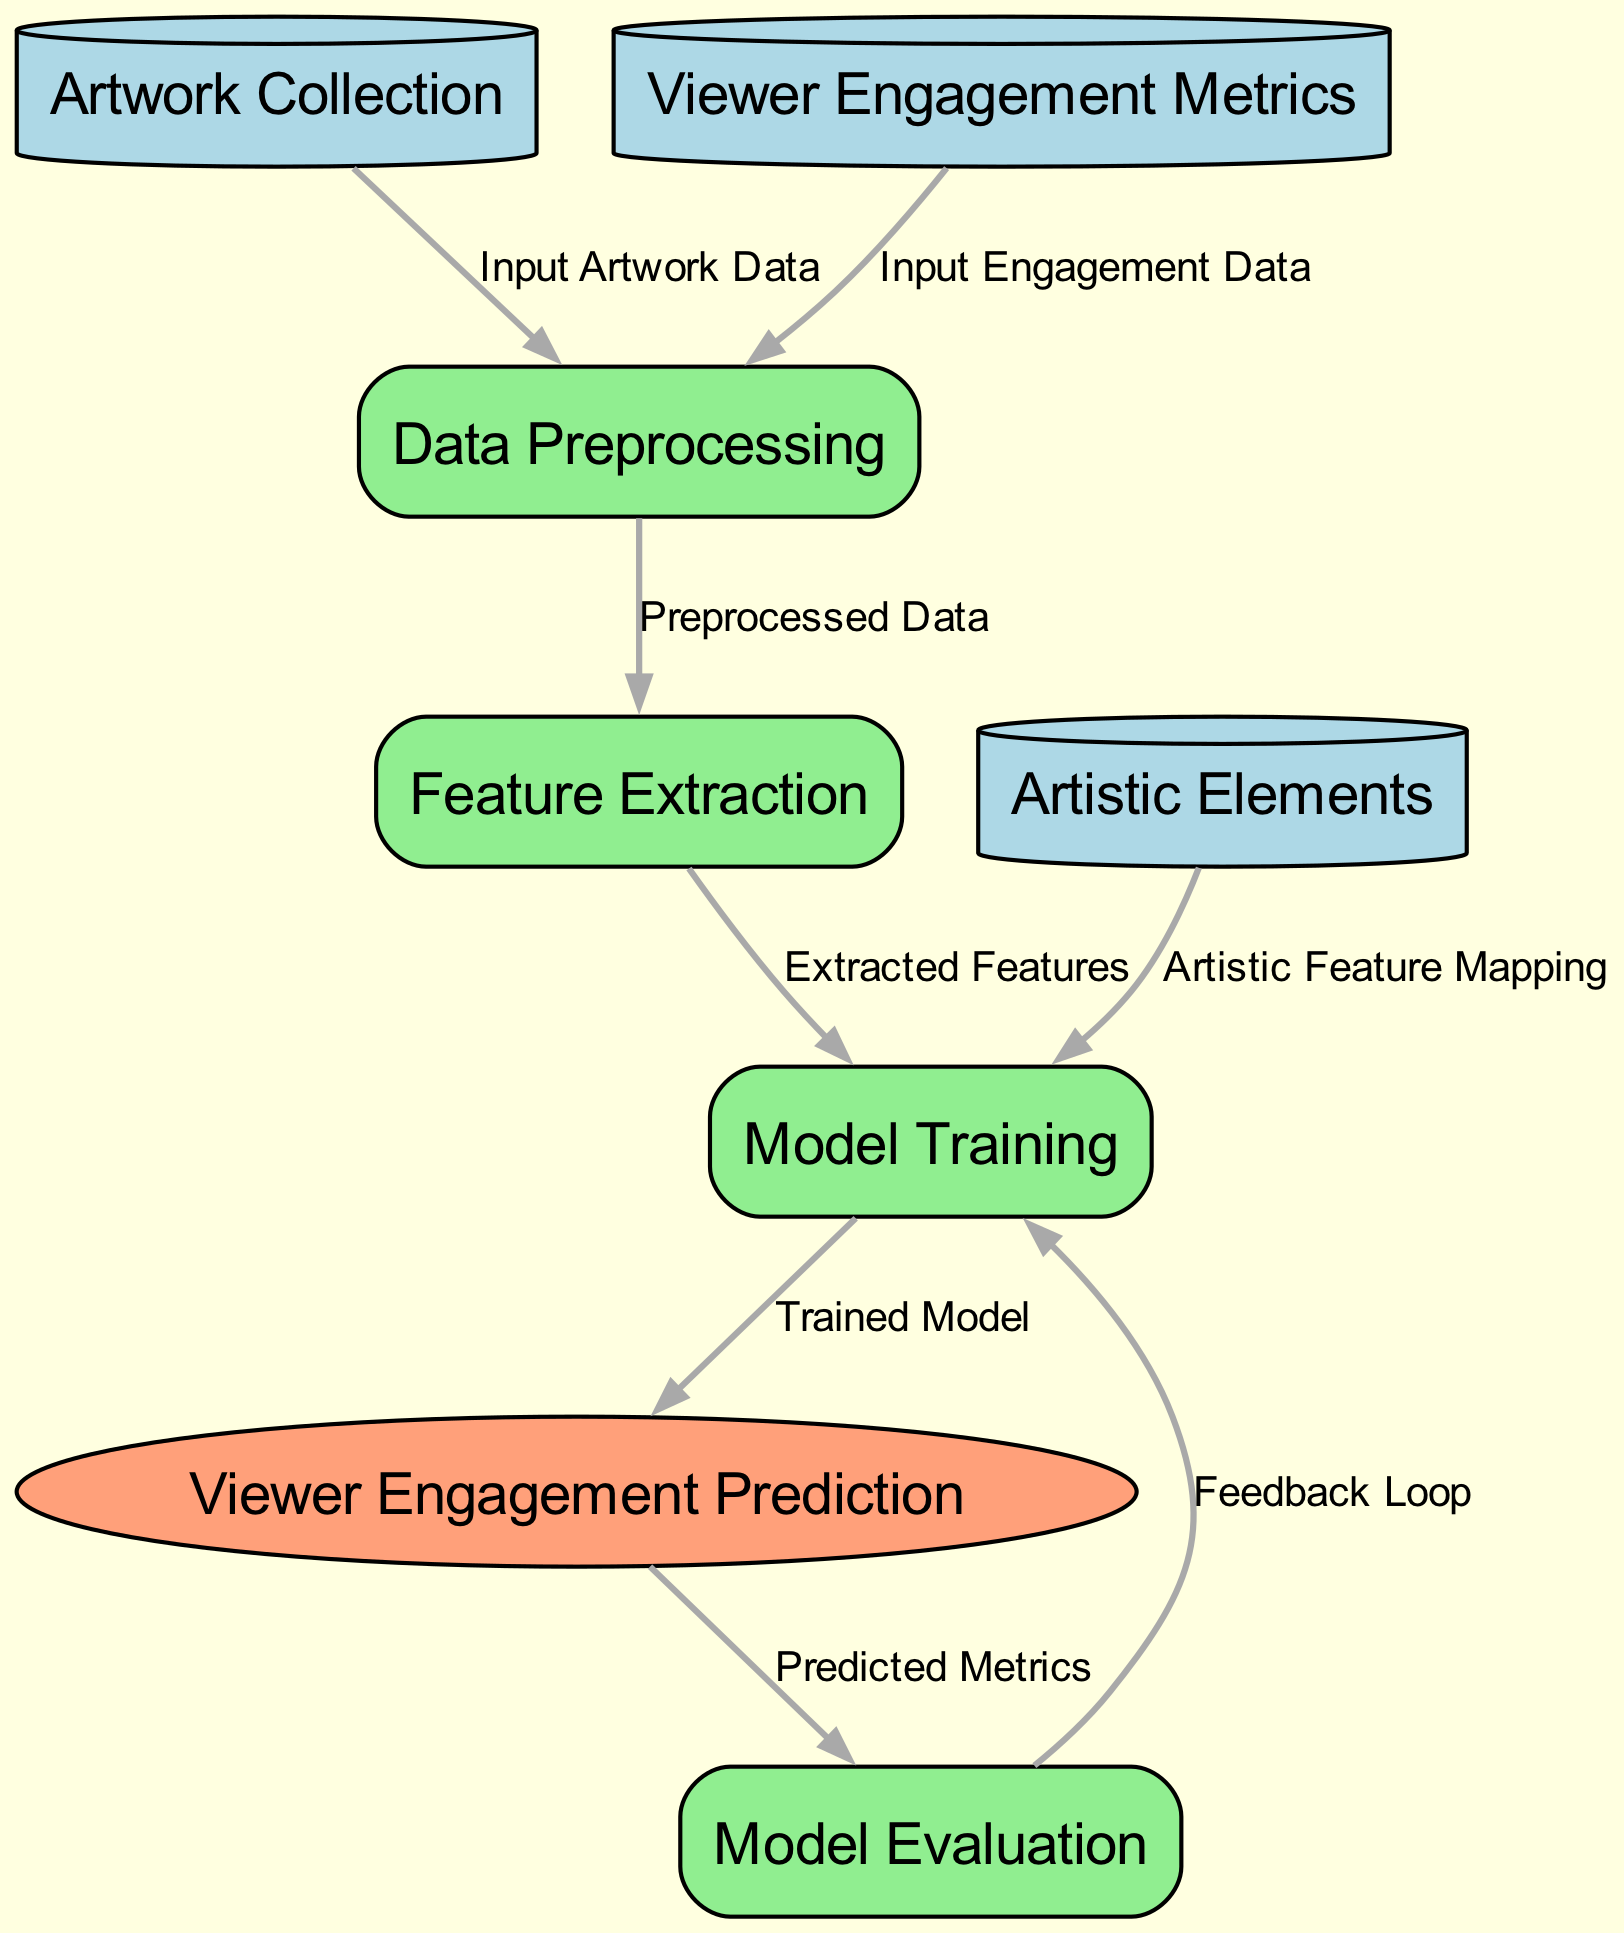What is the first process in the diagram? The diagram shows that the first process is "Data Preprocessing," as it is the process that directly follows the input nodes for "Artwork Collection" and "Viewer Engagement Metrics."
Answer: Data Preprocessing How many edges are there connecting nodes in the diagram? By counting the connections between nodes, we find that there are a total of eight edges in the diagram, indicating the relationships between different nodes.
Answer: 8 What outputs directly from the "Model Training" process? The output from the "Model Training" process is "Viewer Engagement Prediction," which is directly connected and follows the model training step in the diagram.
Answer: Viewer Engagement Prediction What is the purpose of the "Feature Extraction" process in the diagram? The "Feature Extraction" process takes "Preprocessed Data" from "Data Preprocessing" as input and supplies the "Extracted Features" to the "Model Training" process, thus its purpose is to extract relevant features from the artwork engagement data.
Answer: Extracted Features Which node provides input for both "Data Preprocessing" processes? The node "Artwork Collection" provides input to the "Data Preprocessing" process, as well as "Viewer Engagement Metrics," indicating that it contributes to both input paths.
Answer: Artwork Collection What type of outcome does the "engagementPrediction" node represent? The "engagementPrediction" node represents an outcome, as indicated in the diagram, and it follows the model training, predicting viewer engagement metrics based on the model's training and extracted features.
Answer: Outcome How does "Model Evaluation" relate to "Model Training"? "Model Evaluation" is related to "Model Training" through a feedback loop where the predicted metrics from "Viewer Engagement Prediction" are evaluated to improve or adjust the model training process. This is indicated by the back edge connecting these elements.
Answer: Feedback Loop What follows after "Model Evaluation"? After "Model Evaluation," there is a feedback loop that points back to "Model Training," indicating that the evaluation leads to further training adjustments or improvements in the model.
Answer: Model Training 